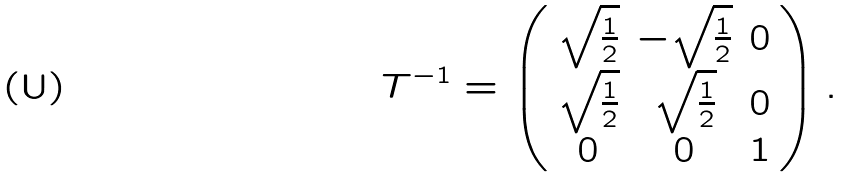Convert formula to latex. <formula><loc_0><loc_0><loc_500><loc_500>T ^ { - 1 } = \left ( \begin{array} { c c c } \sqrt { \frac { 1 } { 2 } } & - \sqrt { \frac { 1 } { 2 } } & 0 \\ \sqrt { \frac { 1 } { 2 } } & \sqrt { \frac { 1 } { 2 } } & 0 \\ 0 & 0 & 1 \\ \end{array} \right ) .</formula> 